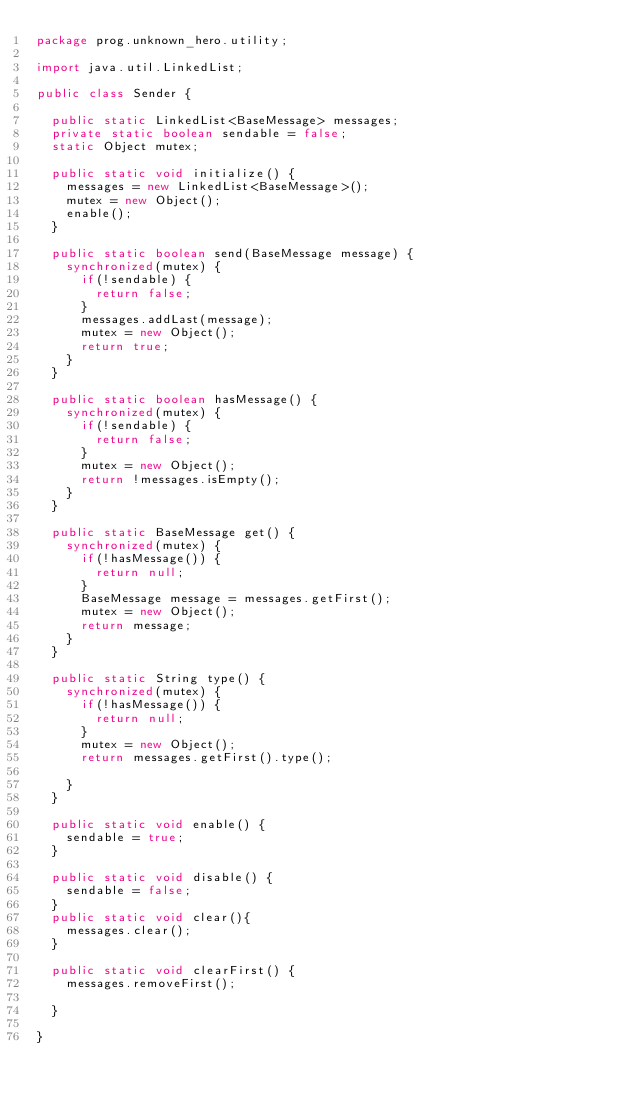Convert code to text. <code><loc_0><loc_0><loc_500><loc_500><_Java_>package prog.unknown_hero.utility;

import java.util.LinkedList;

public class Sender {

	public static LinkedList<BaseMessage> messages;
	private static boolean sendable = false;
	static Object mutex;
	
	public static void initialize() {
		messages = new LinkedList<BaseMessage>();
		mutex = new Object();
		enable();
	}
	
	public static boolean send(BaseMessage message) {
		synchronized(mutex) {
			if(!sendable) {
				return false;
			}
			messages.addLast(message);
			mutex = new Object();
			return true;
		}
	}
	
	public static boolean hasMessage() {
		synchronized(mutex) {
			if(!sendable) {
				return false;
			}
			mutex = new Object();
			return !messages.isEmpty();
		}
	}
	
	public static BaseMessage get() {
		synchronized(mutex) {
			if(!hasMessage()) {
				return null;
			}
			BaseMessage message = messages.getFirst();
			mutex = new Object();
			return message;
		}
	}
	
	public static String type() {
		synchronized(mutex) {
			if(!hasMessage()) {
				return null;
			}
			mutex = new Object();
			return messages.getFirst().type();
			
		}
	}
	
	public static void enable() {
		sendable = true;
	}
	
	public static void disable() {
		sendable = false;
	}
	public static void clear(){
		messages.clear();
	}

	public static void clearFirst() {
		messages.removeFirst();
		
	}

}
</code> 